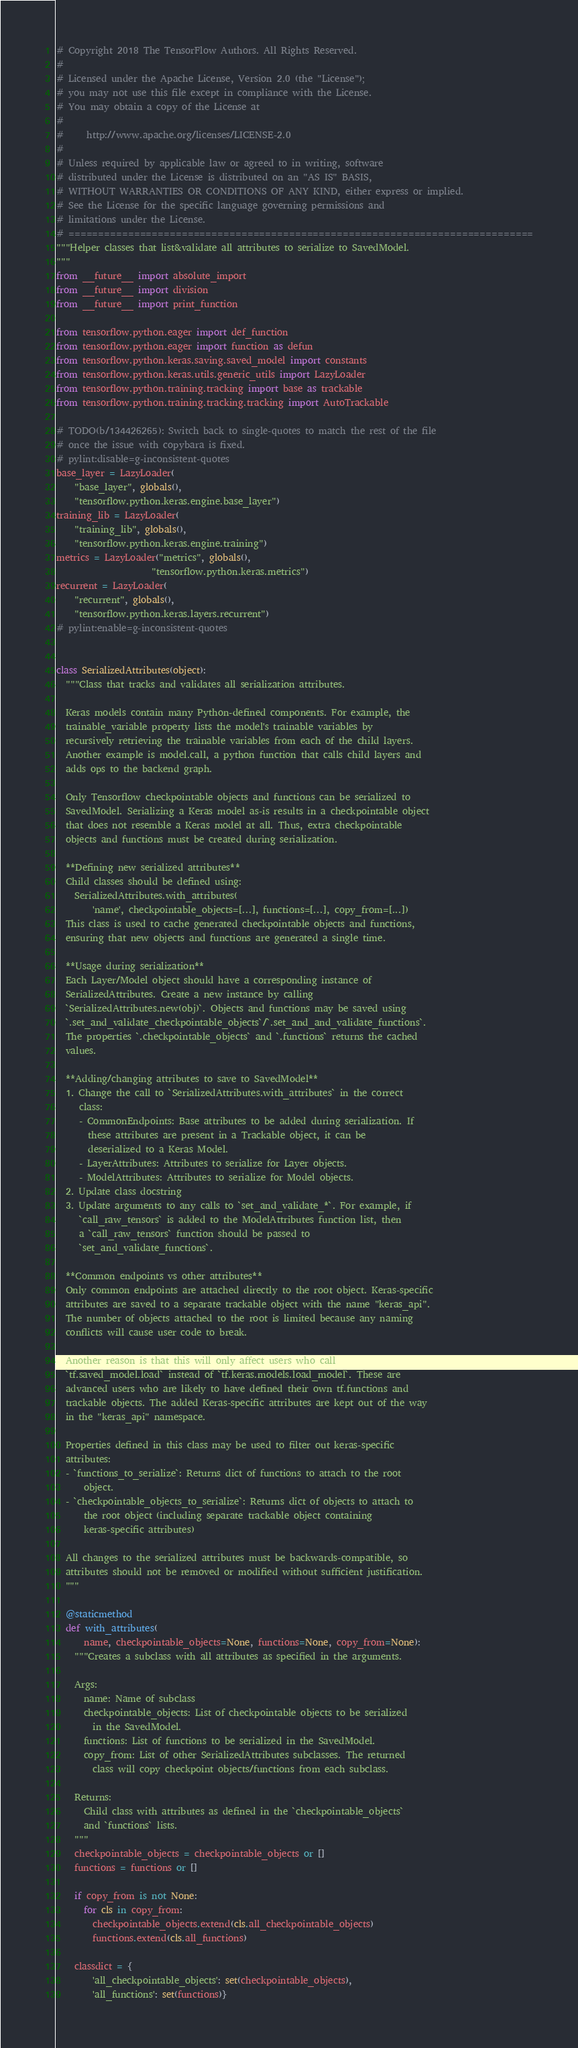Convert code to text. <code><loc_0><loc_0><loc_500><loc_500><_Python_># Copyright 2018 The TensorFlow Authors. All Rights Reserved.
#
# Licensed under the Apache License, Version 2.0 (the "License");
# you may not use this file except in compliance with the License.
# You may obtain a copy of the License at
#
#     http://www.apache.org/licenses/LICENSE-2.0
#
# Unless required by applicable law or agreed to in writing, software
# distributed under the License is distributed on an "AS IS" BASIS,
# WITHOUT WARRANTIES OR CONDITIONS OF ANY KIND, either express or implied.
# See the License for the specific language governing permissions and
# limitations under the License.
# ==============================================================================
"""Helper classes that list&validate all attributes to serialize to SavedModel.
"""
from __future__ import absolute_import
from __future__ import division
from __future__ import print_function

from tensorflow.python.eager import def_function
from tensorflow.python.eager import function as defun
from tensorflow.python.keras.saving.saved_model import constants
from tensorflow.python.keras.utils.generic_utils import LazyLoader
from tensorflow.python.training.tracking import base as trackable
from tensorflow.python.training.tracking.tracking import AutoTrackable

# TODO(b/134426265): Switch back to single-quotes to match the rest of the file
# once the issue with copybara is fixed.
# pylint:disable=g-inconsistent-quotes
base_layer = LazyLoader(
    "base_layer", globals(),
    "tensorflow.python.keras.engine.base_layer")
training_lib = LazyLoader(
    "training_lib", globals(),
    "tensorflow.python.keras.engine.training")
metrics = LazyLoader("metrics", globals(),
                     "tensorflow.python.keras.metrics")
recurrent = LazyLoader(
    "recurrent", globals(),
    "tensorflow.python.keras.layers.recurrent")
# pylint:enable=g-inconsistent-quotes


class SerializedAttributes(object):
  """Class that tracks and validates all serialization attributes.

  Keras models contain many Python-defined components. For example, the
  trainable_variable property lists the model's trainable variables by
  recursively retrieving the trainable variables from each of the child layers.
  Another example is model.call, a python function that calls child layers and
  adds ops to the backend graph.

  Only Tensorflow checkpointable objects and functions can be serialized to
  SavedModel. Serializing a Keras model as-is results in a checkpointable object
  that does not resemble a Keras model at all. Thus, extra checkpointable
  objects and functions must be created during serialization.

  **Defining new serialized attributes**
  Child classes should be defined using:
    SerializedAttributes.with_attributes(
        'name', checkpointable_objects=[...], functions=[...], copy_from=[...])
  This class is used to cache generated checkpointable objects and functions,
  ensuring that new objects and functions are generated a single time.

  **Usage during serialization**
  Each Layer/Model object should have a corresponding instance of
  SerializedAttributes. Create a new instance by calling
  `SerializedAttributes.new(obj)`. Objects and functions may be saved using
  `.set_and_validate_checkpointable_objects`/`.set_and_and_validate_functions`.
  The properties `.checkpointable_objects` and `.functions` returns the cached
  values.

  **Adding/changing attributes to save to SavedModel**
  1. Change the call to `SerializedAttributes.with_attributes` in the correct
     class:
     - CommonEndpoints: Base attributes to be added during serialization. If
       these attributes are present in a Trackable object, it can be
       deserialized to a Keras Model.
     - LayerAttributes: Attributes to serialize for Layer objects.
     - ModelAttributes: Attributes to serialize for Model objects.
  2. Update class docstring
  3. Update arguments to any calls to `set_and_validate_*`. For example, if
     `call_raw_tensors` is added to the ModelAttributes function list, then
     a `call_raw_tensors` function should be passed to
     `set_and_validate_functions`.

  **Common endpoints vs other attributes**
  Only common endpoints are attached directly to the root object. Keras-specific
  attributes are saved to a separate trackable object with the name "keras_api".
  The number of objects attached to the root is limited because any naming
  conflicts will cause user code to break.

  Another reason is that this will only affect users who call
  `tf.saved_model.load` instead of `tf.keras.models.load_model`. These are
  advanced users who are likely to have defined their own tf.functions and
  trackable objects. The added Keras-specific attributes are kept out of the way
  in the "keras_api" namespace.

  Properties defined in this class may be used to filter out keras-specific
  attributes:
  - `functions_to_serialize`: Returns dict of functions to attach to the root
      object.
  - `checkpointable_objects_to_serialize`: Returns dict of objects to attach to
      the root object (including separate trackable object containing
      keras-specific attributes)

  All changes to the serialized attributes must be backwards-compatible, so
  attributes should not be removed or modified without sufficient justification.
  """

  @staticmethod
  def with_attributes(
      name, checkpointable_objects=None, functions=None, copy_from=None):
    """Creates a subclass with all attributes as specified in the arguments.

    Args:
      name: Name of subclass
      checkpointable_objects: List of checkpointable objects to be serialized
        in the SavedModel.
      functions: List of functions to be serialized in the SavedModel.
      copy_from: List of other SerializedAttributes subclasses. The returned
        class will copy checkpoint objects/functions from each subclass.

    Returns:
      Child class with attributes as defined in the `checkpointable_objects`
      and `functions` lists.
    """
    checkpointable_objects = checkpointable_objects or []
    functions = functions or []

    if copy_from is not None:
      for cls in copy_from:
        checkpointable_objects.extend(cls.all_checkpointable_objects)
        functions.extend(cls.all_functions)

    classdict = {
        'all_checkpointable_objects': set(checkpointable_objects),
        'all_functions': set(functions)}</code> 